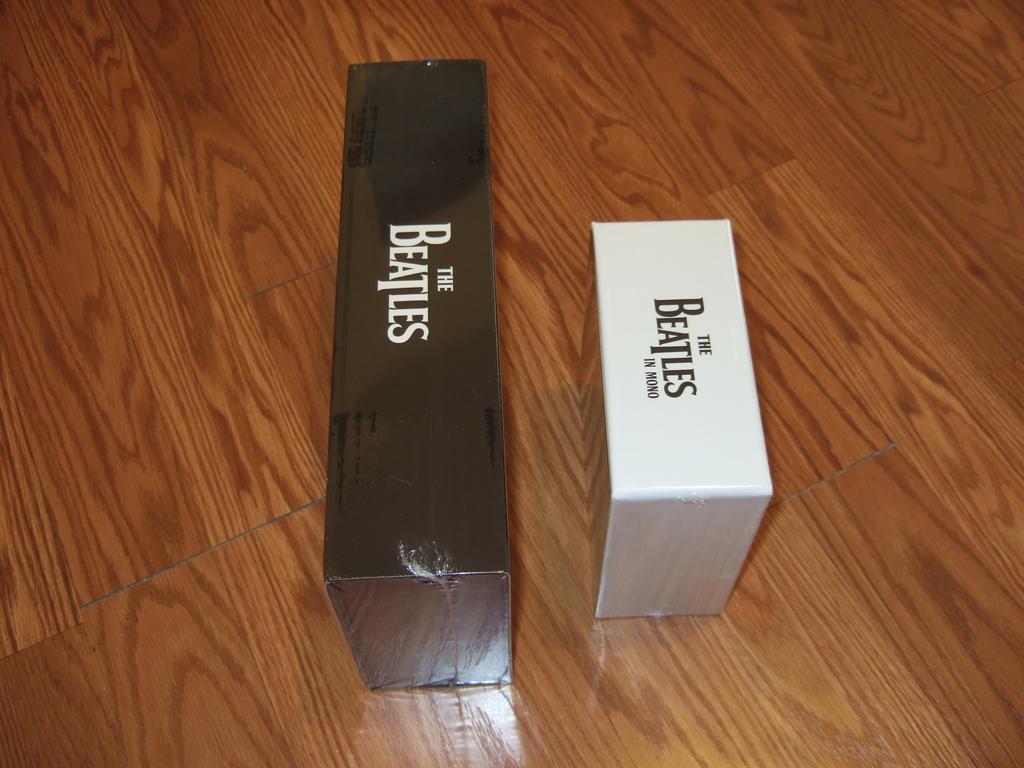What band is in this box?
Your answer should be very brief. The beatles. What does the white text on the black box say?
Provide a succinct answer. The beatles. 